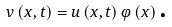Convert formula to latex. <formula><loc_0><loc_0><loc_500><loc_500>v \left ( x , t \right ) = u \left ( x , t \right ) \varphi \left ( x \right ) \text {.}</formula> 